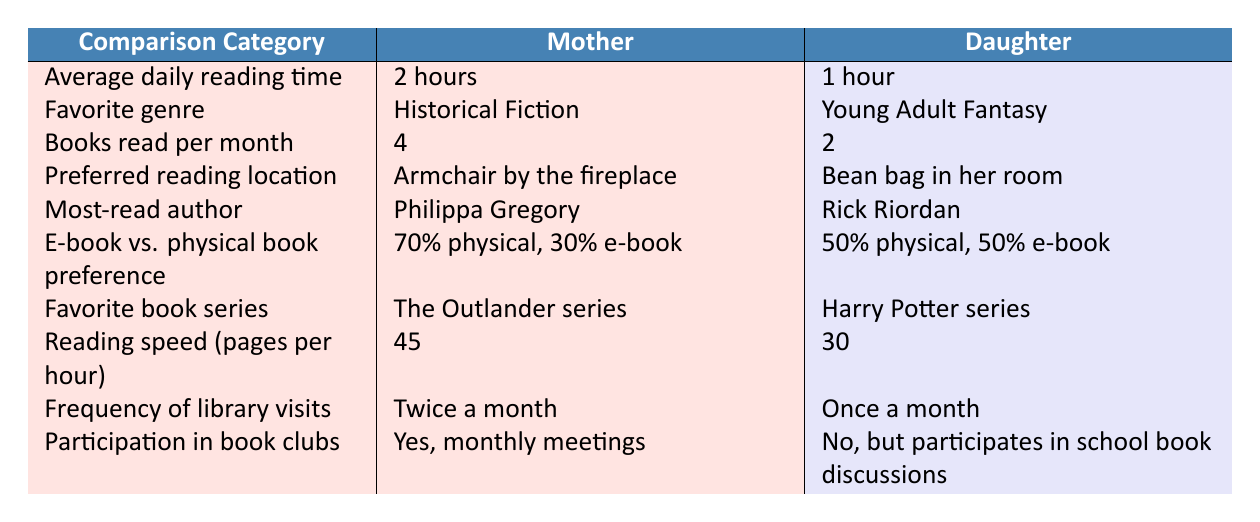What's the average daily reading time for the mother? The table lists the mother’s average daily reading time as 2 hours.
Answer: 2 hours What is the favorite genre of the daughter? According to the table, the favorite genre listed for the daughter is Young Adult Fantasy.
Answer: Young Adult Fantasy How many books does the mother read per month? The table indicates that the mother reads 4 books per month.
Answer: 4 What is the preferred reading location for the daughter? The daughter prefers to read in her bean bag in her room as shown in the table.
Answer: Bean bag in her room Who is the most-read author for the mother? Based on the table, the mother’s most-read author is Philippa Gregory.
Answer: Philippa Gregory What is the difference in reading speed between the mother and daughter? The mother reads at 45 pages per hour while the daughter reads at 30 pages per hour, so the difference is 45 - 30 = 15 pages per hour.
Answer: 15 pages per hour Does the daughter participate in book clubs? The table states that the daughter does not participate in book clubs but is involved in school book discussions.
Answer: No How many times does the mother visit the library compared to the daughter? The mother visits the library twice a month while the daughter visits once a month, resulting in a difference of 2 - 1 = 1 visit per month more for the mother.
Answer: 1 visit per month Which reading format is preferred more by the mother, physical or e-book? The table shows that the mother prefers physical books at a rate of 70%, compared to 30% for e-books.
Answer: Physical books What is the combined total of books read per month by both mother and daughter? The mother reads 4 books and the daughter reads 2 books. Adding these gives a total of 4 + 2 = 6 books read per month.
Answer: 6 books per month 